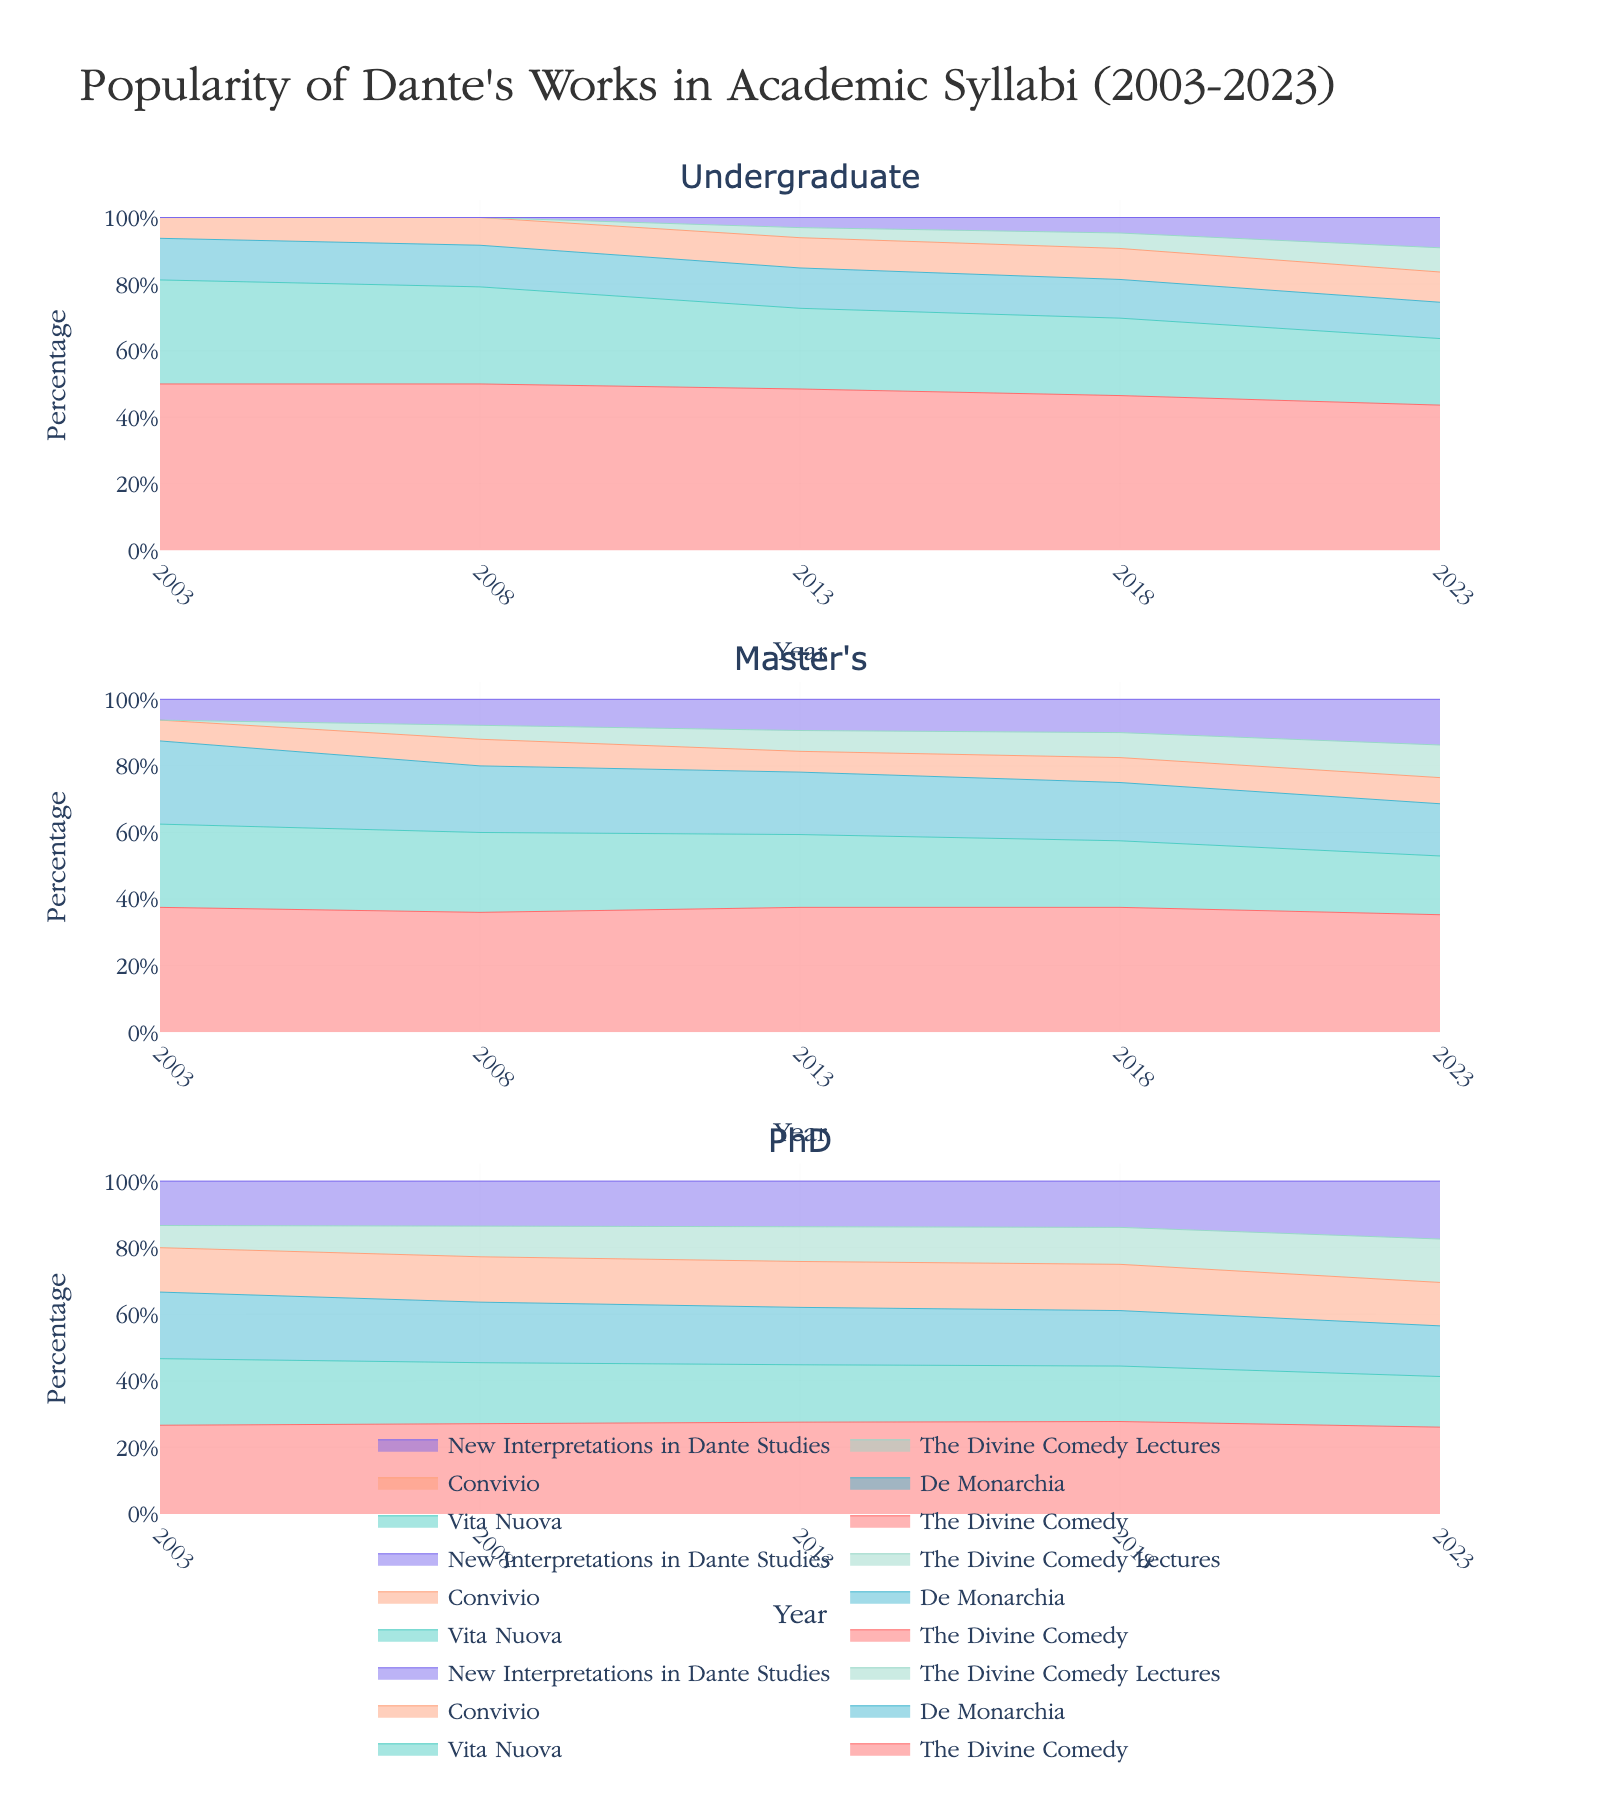What is the title of the figure? The title of the figure is located at the top and centrally aligned. It is "Popularity of Dante's Works in Academic Syllabi (2003-2023)".
Answer: Popularity of Dante's Works in Academic Syllabi (2003-2023) Which program shows the highest percentage of "The Divine Comedy" in 2023? To find this, look at the subplots for 2023 and identify the program with the highest visible area for "The Divine Comedy". It is most prominent in the Undergraduate subplot.
Answer: Undergraduate How has the popularity of "The Divine Comedy" changed in undergraduate syllabi from 2003 to 2023? Observing the first subplot for undergraduates from 2003 to 2023, the proportionate area for "The Divine Comedy" has increased consistently over the years.
Answer: Increased In which program was "Convivio" included in the syllabi from 2003 to 2008? By checking the presence of "Convivio" in the period between 2003 and 2008, it can be seen only in the Master's and PhD programs.
Answer: Master's and PhD What was the new introduction to the undergraduate syllabi in 2013? Referring to the undergraduate subplot for 2013, "The Divine Comedy Lectures" and "New Interpretations in Dante Studies" appear as new entries.
Answer: The Divine Comedy Lectures and New Interpretations in Dante Studies Compare the popularity of "Vita Nuova" and "De Monarchia" in Master's programs in 2018. Which one is more popular? For 2018, look at the Master's subplots and compare the heights of the areas representing "Vita Nuova" and "De Monarchia". "Vita Nuova" has a larger area.
Answer: Vita Nuova Has "New Interpretations in Dante Studies" been part of the syllabi in any program before 2008? Verify the presence of any area corresponding to "New Interpretations in Dante Studies" in the subplots before 2008 for all programs. The area appears only from 2008 onwards.
Answer: No Which program has shown the most significant growth in the inclusion of "De Monarchia" from 2003 to 2023? By examining the change in the area size for "De Monarchia" in each program's subplot from 2003 to 2023, the Master's program shows the most significant growth.
Answer: Master's What is the combined percentage share of "The Divine Comedy" and "The Divine Comedy Lectures" in PhD programs in 2023? In the PhD subplot for 2023, add the percentages for "The Divine Comedy" and "The Divine Comedy Lectures" which are approximately 60% and 30% respectively.
Answer: 90% 